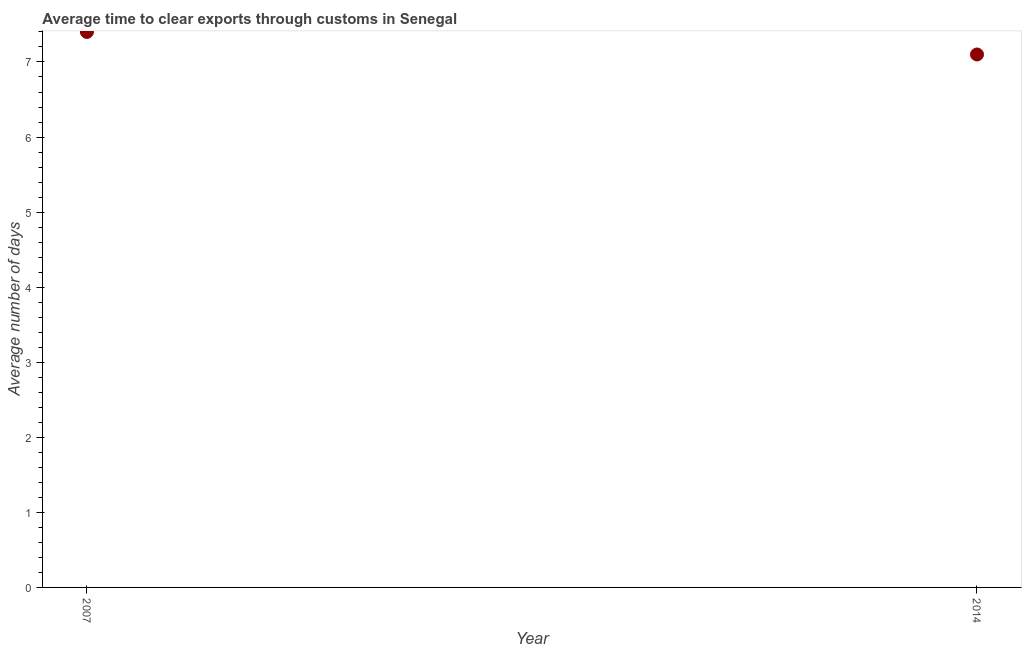What is the time to clear exports through customs in 2007?
Your answer should be very brief. 7.4. Across all years, what is the maximum time to clear exports through customs?
Provide a succinct answer. 7.4. In which year was the time to clear exports through customs minimum?
Keep it short and to the point. 2014. What is the sum of the time to clear exports through customs?
Your answer should be very brief. 14.5. What is the difference between the time to clear exports through customs in 2007 and 2014?
Make the answer very short. 0.3. What is the average time to clear exports through customs per year?
Offer a very short reply. 7.25. What is the median time to clear exports through customs?
Offer a terse response. 7.25. What is the ratio of the time to clear exports through customs in 2007 to that in 2014?
Keep it short and to the point. 1.04. Is the time to clear exports through customs in 2007 less than that in 2014?
Your response must be concise. No. In how many years, is the time to clear exports through customs greater than the average time to clear exports through customs taken over all years?
Your answer should be very brief. 1. Does the time to clear exports through customs monotonically increase over the years?
Offer a very short reply. No. How many dotlines are there?
Keep it short and to the point. 1. How many years are there in the graph?
Provide a short and direct response. 2. What is the difference between two consecutive major ticks on the Y-axis?
Provide a short and direct response. 1. Does the graph contain any zero values?
Give a very brief answer. No. Does the graph contain grids?
Provide a short and direct response. No. What is the title of the graph?
Make the answer very short. Average time to clear exports through customs in Senegal. What is the label or title of the Y-axis?
Your answer should be compact. Average number of days. What is the Average number of days in 2014?
Your answer should be compact. 7.1. What is the ratio of the Average number of days in 2007 to that in 2014?
Make the answer very short. 1.04. 